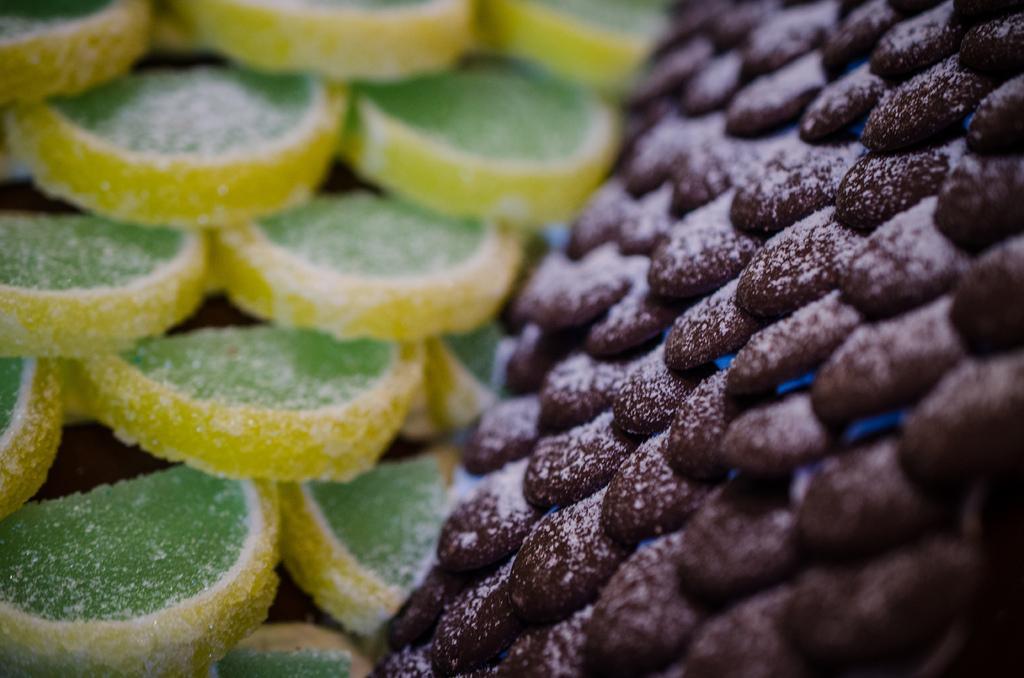Describe this image in one or two sentences. In this image at front we can see sugar candies. 